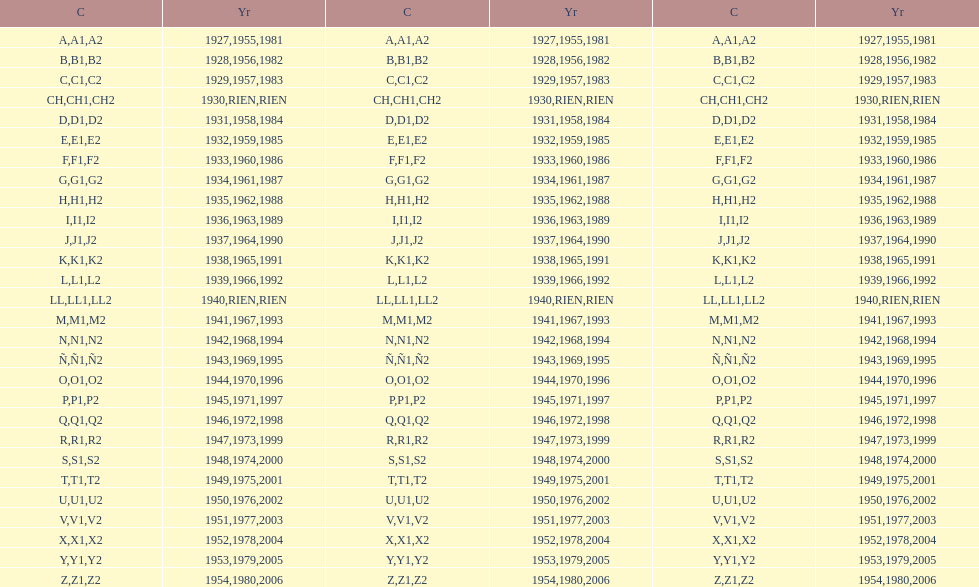List each code not associated to a year. CH1, CH2, LL1, LL2. 